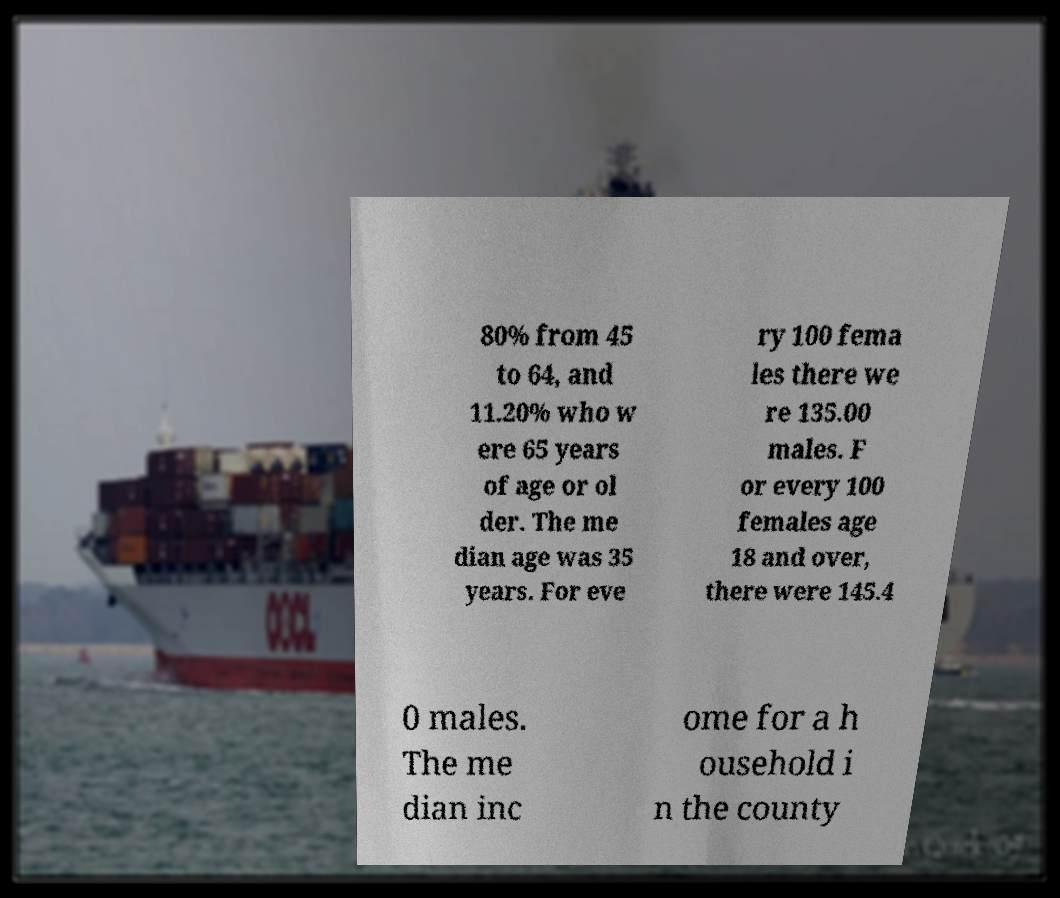What messages or text are displayed in this image? I need them in a readable, typed format. 80% from 45 to 64, and 11.20% who w ere 65 years of age or ol der. The me dian age was 35 years. For eve ry 100 fema les there we re 135.00 males. F or every 100 females age 18 and over, there were 145.4 0 males. The me dian inc ome for a h ousehold i n the county 